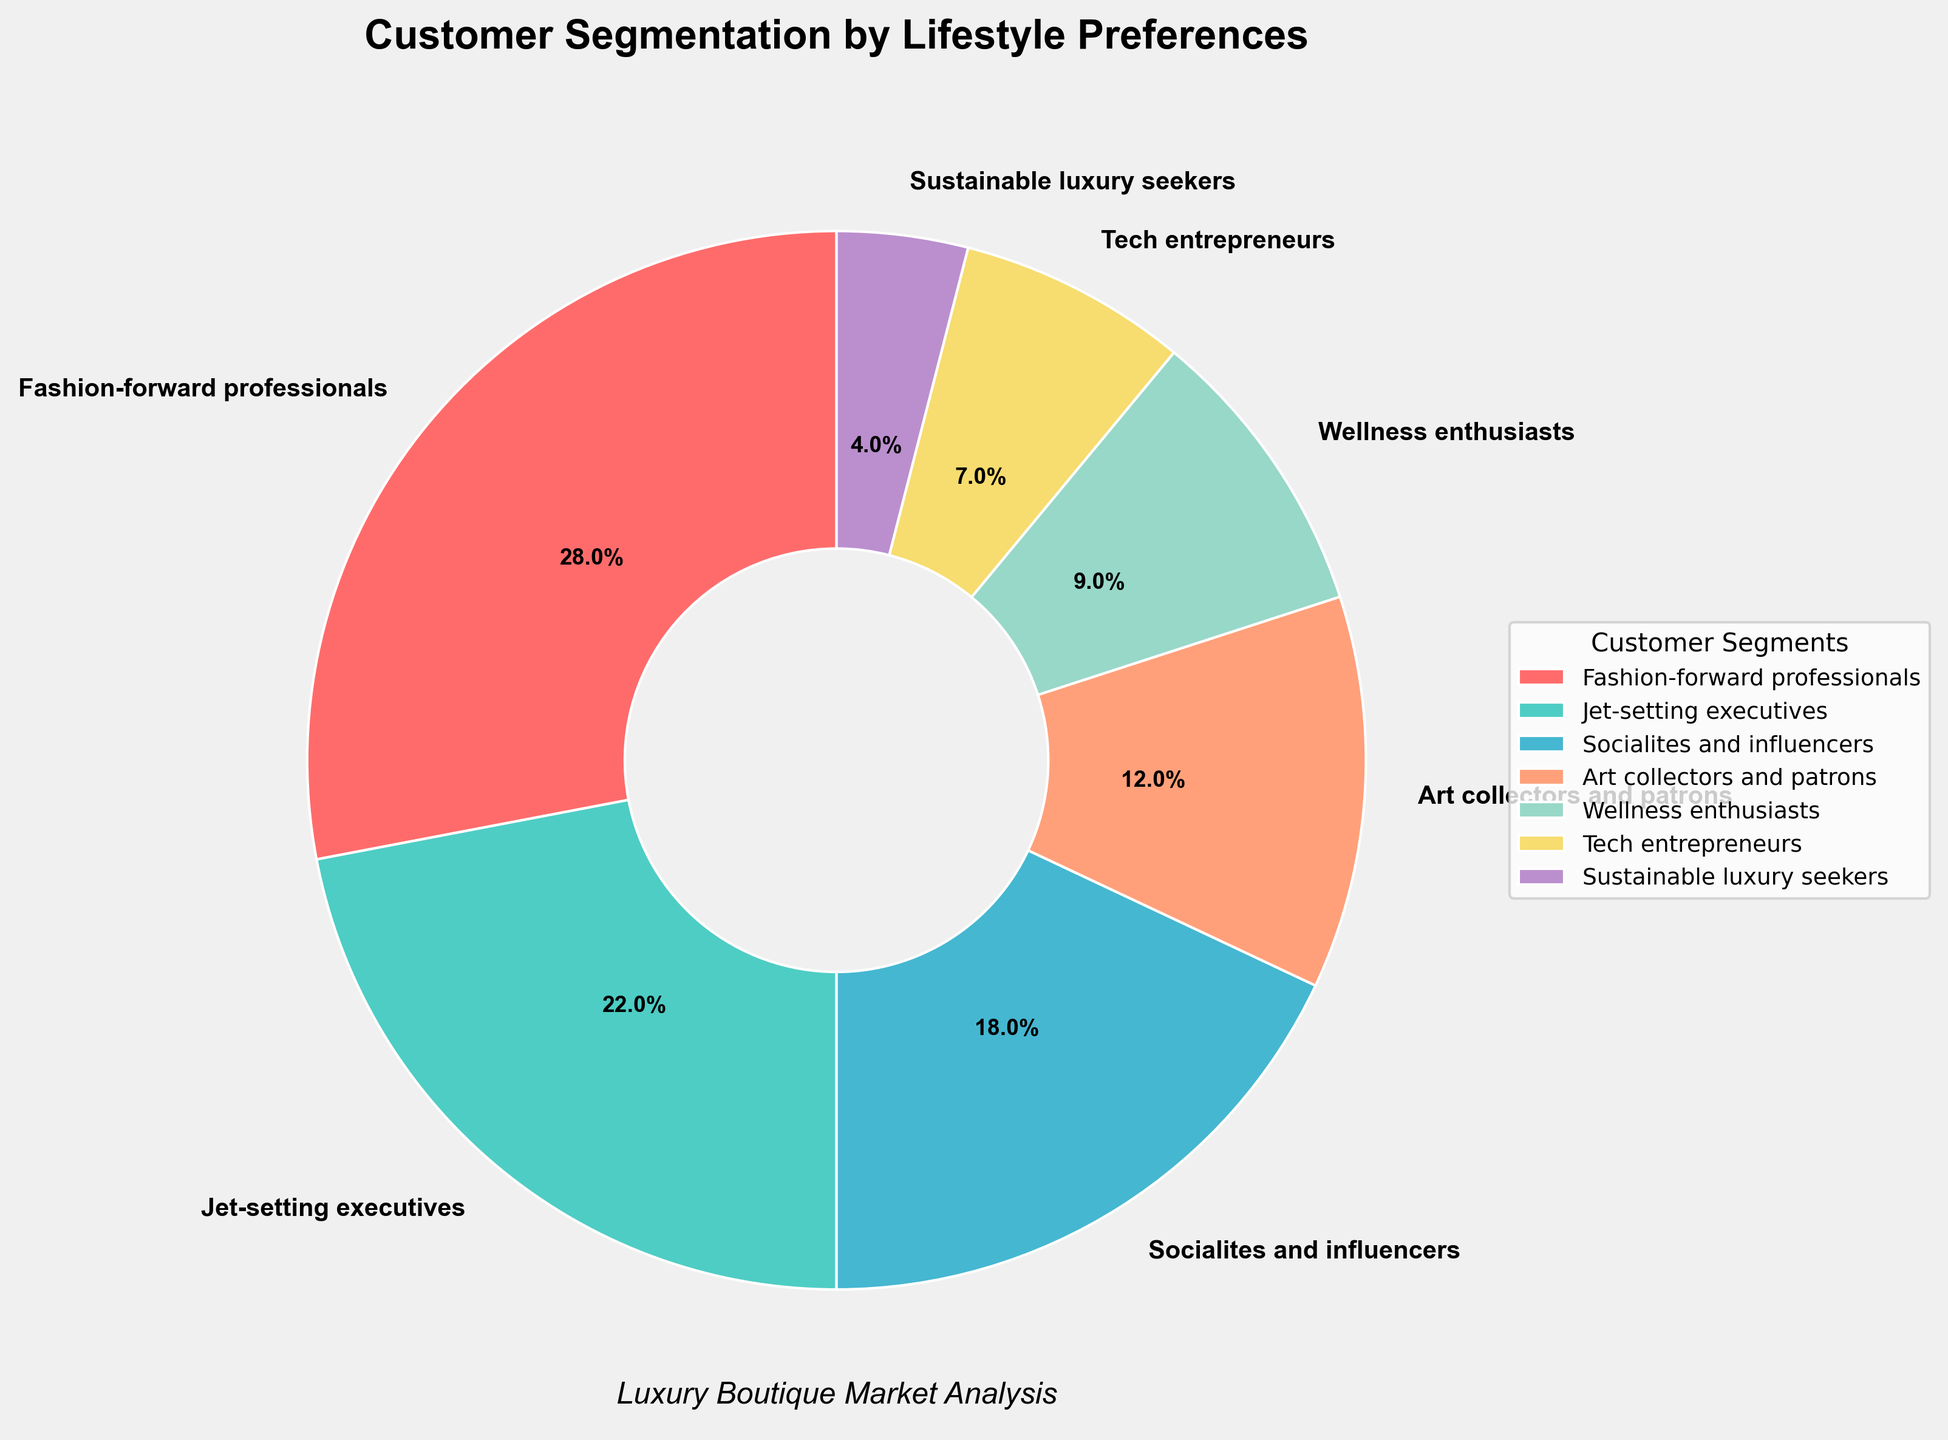What's the largest customer segment? The pie chart lists all segments with their percentages. The "Fashion-forward professionals" segment has the highest percentage, which is 28%.
Answer: Fashion-forward professionals Which segment has a larger percentage: Jet-setting executives or Socialites and influencers? The pie chart shows that "Jet-setting executives" have 22% and "Socialites and influencers" have 18%. 22% is greater than 18%.
Answer: Jet-setting executives What is the combined percentage of Art collectors and patrons and Wellness enthusiasts? From the pie chart, "Art collectors and patrons" contribute 12% and "Wellness enthusiasts" account for 9%. Summing up these percentages gives 12% + 9% = 21%.
Answer: 21% Which segment has the smallest percentage? The pie chart indicates that the "Sustainable luxury seekers" segment has the smallest percentage, at 4%.
Answer: Sustainable luxury seekers Is the percentage of Tech entrepreneurs more than one-third of the percentage of Fashion-forward professionals? The percentage for "Fashion-forward professionals" is 28%. One-third of this value is approximately 9.33% (28% / 3). The percentage for "Tech entrepreneurs" is 7%, which is less than 9.33%.
Answer: No How many segments have a percentage greater than 10%? By examining the pie chart, the segments with percentages greater than 10% are "Fashion-forward professionals" (28%), "Jet-setting executives" (22%), "Socialites and influencers" (18%), and "Art collectors and patrons" (12%). There are 4 such segments.
Answer: 4 What color represents the Wellness enthusiasts segment? The pie chart uses distinct colors for each segment. "Wellness enthusiasts" are represented by a color that appears yellowish-gold.
Answer: Yellowish-gold What's the difference in percentage between Socialites and influencers and Tech entrepreneurs? In the pie chart, "Socialites and influencers" have 18% and "Tech entrepreneurs" have 7%. The difference between these percentages is 18% - 7% = 11%.
Answer: 11% Which segment has a percentage closest to 5%? From the pie chart, "Sustainable luxury seekers" have 4%, which is the closest percentage to 5%.
Answer: Sustainable luxury seekers Are there more Wellness enthusiasts or Tech entrepreneurs? The pie chart indicates that "Wellness enthusiasts" have 9%, while "Tech entrepreneurs" have 7%. 9% is greater than 7%.
Answer: Wellness enthusiasts 